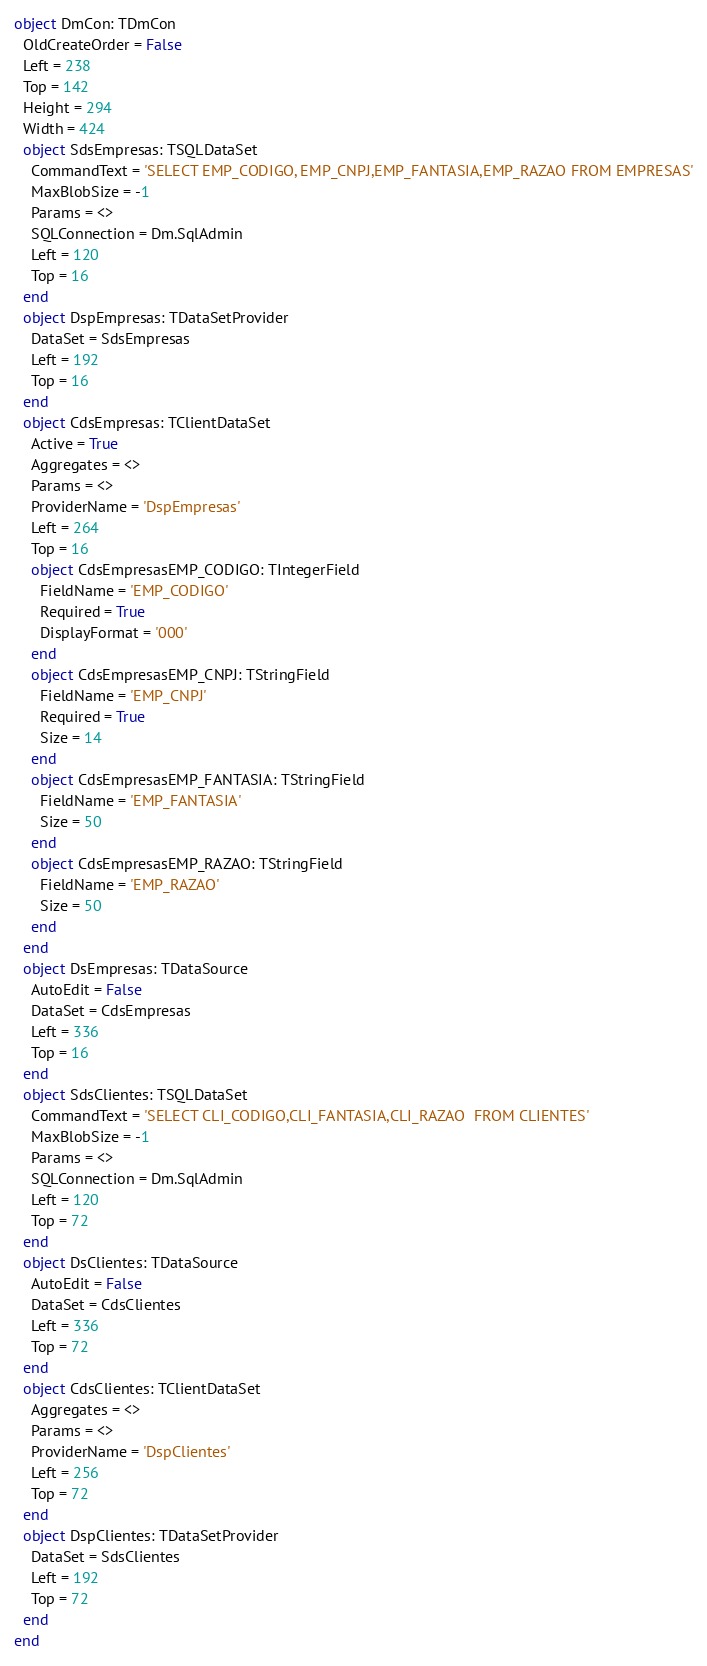Convert code to text. <code><loc_0><loc_0><loc_500><loc_500><_Pascal_>object DmCon: TDmCon
  OldCreateOrder = False
  Left = 238
  Top = 142
  Height = 294
  Width = 424
  object SdsEmpresas: TSQLDataSet
    CommandText = 'SELECT EMP_CODIGO, EMP_CNPJ,EMP_FANTASIA,EMP_RAZAO FROM EMPRESAS'
    MaxBlobSize = -1
    Params = <>
    SQLConnection = Dm.SqlAdmin
    Left = 120
    Top = 16
  end
  object DspEmpresas: TDataSetProvider
    DataSet = SdsEmpresas
    Left = 192
    Top = 16
  end
  object CdsEmpresas: TClientDataSet
    Active = True
    Aggregates = <>
    Params = <>
    ProviderName = 'DspEmpresas'
    Left = 264
    Top = 16
    object CdsEmpresasEMP_CODIGO: TIntegerField
      FieldName = 'EMP_CODIGO'
      Required = True
      DisplayFormat = '000'
    end
    object CdsEmpresasEMP_CNPJ: TStringField
      FieldName = 'EMP_CNPJ'
      Required = True
      Size = 14
    end
    object CdsEmpresasEMP_FANTASIA: TStringField
      FieldName = 'EMP_FANTASIA'
      Size = 50
    end
    object CdsEmpresasEMP_RAZAO: TStringField
      FieldName = 'EMP_RAZAO'
      Size = 50
    end
  end
  object DsEmpresas: TDataSource
    AutoEdit = False
    DataSet = CdsEmpresas
    Left = 336
    Top = 16
  end
  object SdsClientes: TSQLDataSet
    CommandText = 'SELECT CLI_CODIGO,CLI_FANTASIA,CLI_RAZAO  FROM CLIENTES'
    MaxBlobSize = -1
    Params = <>
    SQLConnection = Dm.SqlAdmin
    Left = 120
    Top = 72
  end
  object DsClientes: TDataSource
    AutoEdit = False
    DataSet = CdsClientes
    Left = 336
    Top = 72
  end
  object CdsClientes: TClientDataSet
    Aggregates = <>
    Params = <>
    ProviderName = 'DspClientes'
    Left = 256
    Top = 72
  end
  object DspClientes: TDataSetProvider
    DataSet = SdsClientes
    Left = 192
    Top = 72
  end
end
</code> 